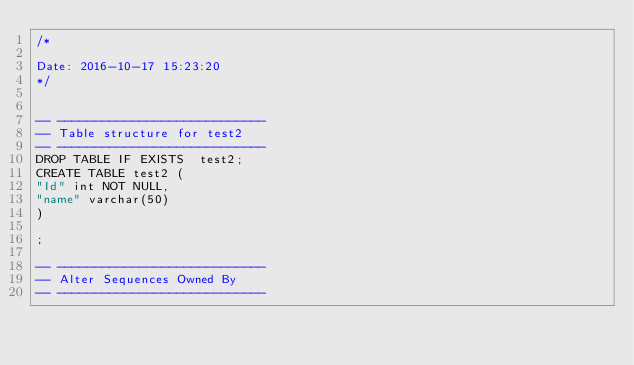Convert code to text. <code><loc_0><loc_0><loc_500><loc_500><_SQL_>/*
 
Date: 2016-10-17 15:23:20
*/


-- ----------------------------
-- Table structure for test2
-- ----------------------------
DROP TABLE IF EXISTS  test2;
CREATE TABLE test2 (
"Id" int NOT NULL,
"name" varchar(50)
)
 
;

-- ----------------------------
-- Alter Sequences Owned By 
-- ----------------------------
</code> 